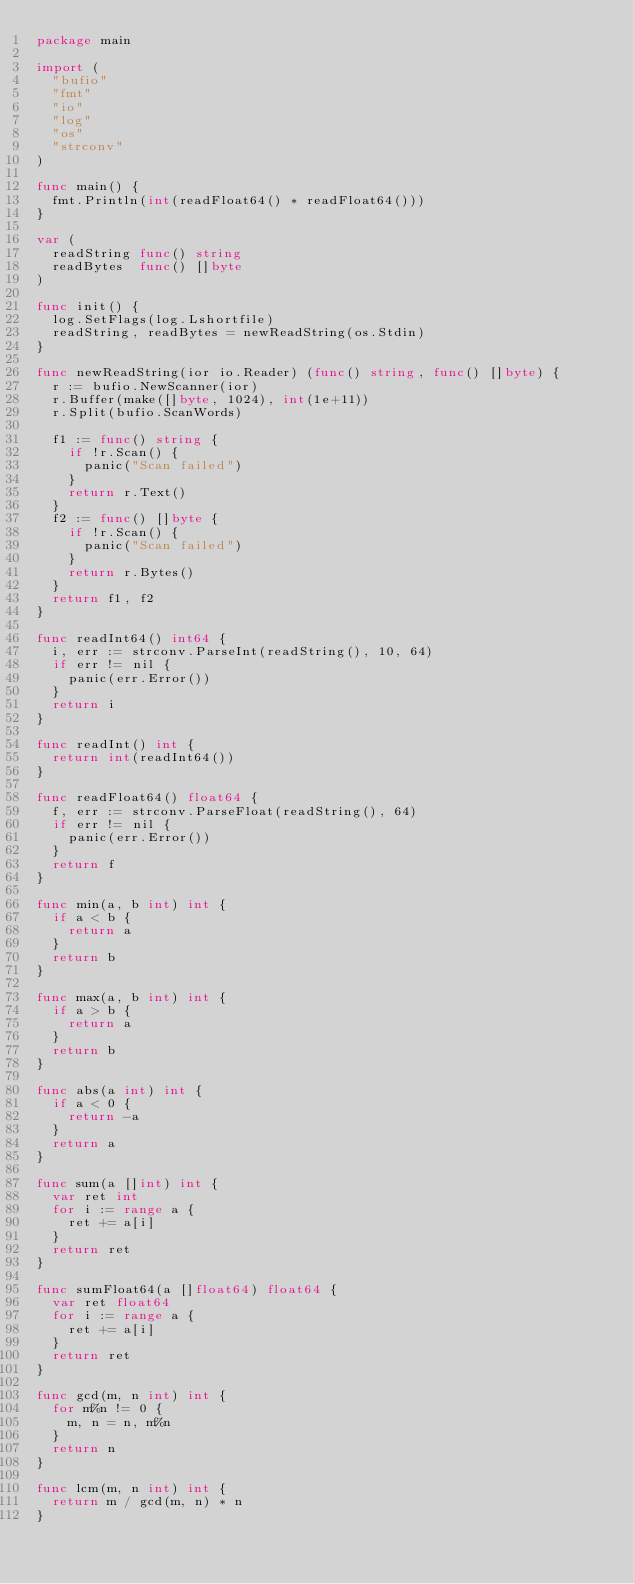<code> <loc_0><loc_0><loc_500><loc_500><_Go_>package main

import (
	"bufio"
	"fmt"
	"io"
	"log"
	"os"
	"strconv"
)

func main() {
	fmt.Println(int(readFloat64() * readFloat64()))
}

var (
	readString func() string
	readBytes  func() []byte
)

func init() {
	log.SetFlags(log.Lshortfile)
	readString, readBytes = newReadString(os.Stdin)
}

func newReadString(ior io.Reader) (func() string, func() []byte) {
	r := bufio.NewScanner(ior)
	r.Buffer(make([]byte, 1024), int(1e+11))
	r.Split(bufio.ScanWords)

	f1 := func() string {
		if !r.Scan() {
			panic("Scan failed")
		}
		return r.Text()
	}
	f2 := func() []byte {
		if !r.Scan() {
			panic("Scan failed")
		}
		return r.Bytes()
	}
	return f1, f2
}

func readInt64() int64 {
	i, err := strconv.ParseInt(readString(), 10, 64)
	if err != nil {
		panic(err.Error())
	}
	return i
}

func readInt() int {
	return int(readInt64())
}

func readFloat64() float64 {
	f, err := strconv.ParseFloat(readString(), 64)
	if err != nil {
		panic(err.Error())
	}
	return f
}

func min(a, b int) int {
	if a < b {
		return a
	}
	return b
}

func max(a, b int) int {
	if a > b {
		return a
	}
	return b
}

func abs(a int) int {
	if a < 0 {
		return -a
	}
	return a
}

func sum(a []int) int {
	var ret int
	for i := range a {
		ret += a[i]
	}
	return ret
}

func sumFloat64(a []float64) float64 {
	var ret float64
	for i := range a {
		ret += a[i]
	}
	return ret
}

func gcd(m, n int) int {
	for m%n != 0 {
		m, n = n, m%n
	}
	return n
}

func lcm(m, n int) int {
	return m / gcd(m, n) * n
}
</code> 